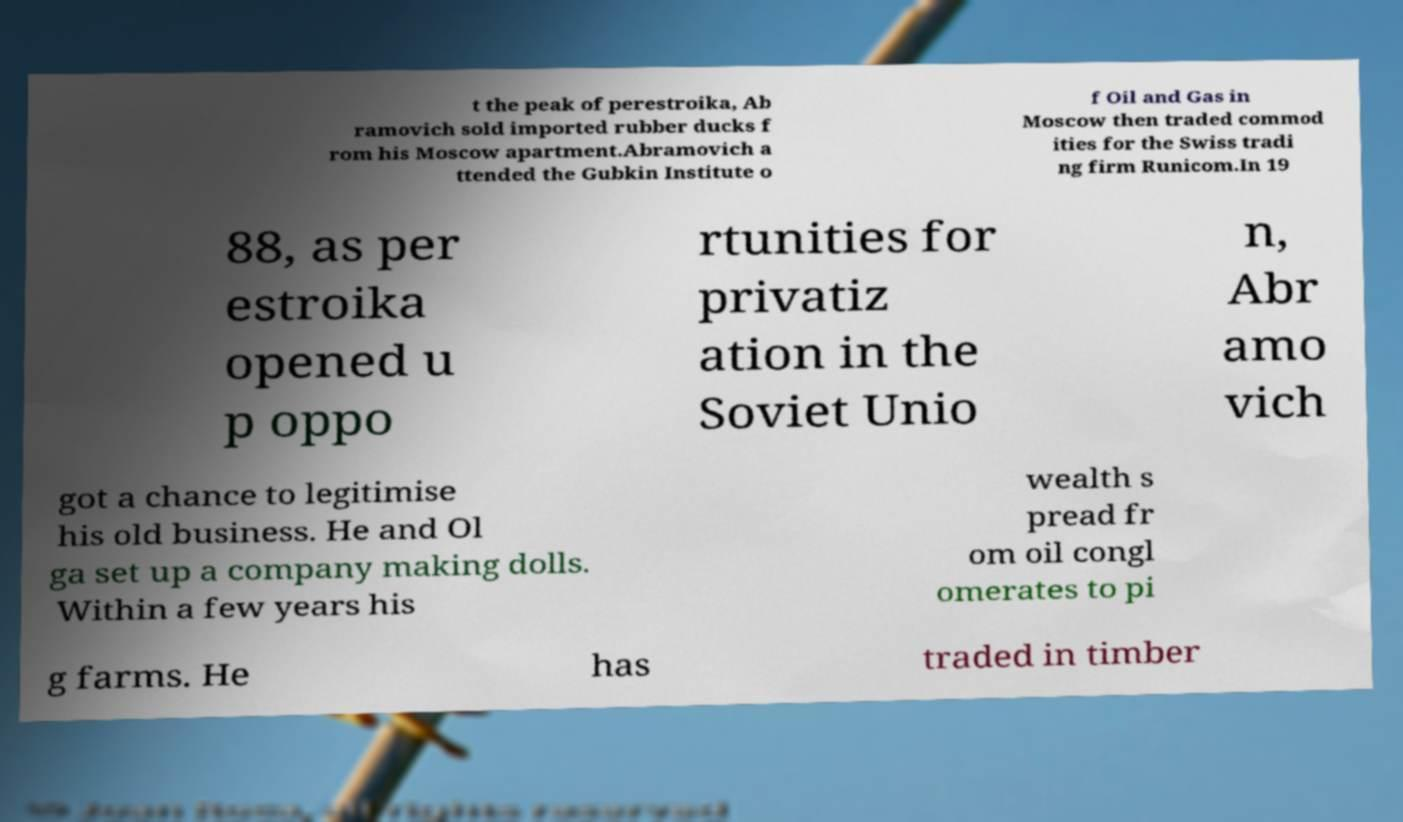There's text embedded in this image that I need extracted. Can you transcribe it verbatim? t the peak of perestroika, Ab ramovich sold imported rubber ducks f rom his Moscow apartment.Abramovich a ttended the Gubkin Institute o f Oil and Gas in Moscow then traded commod ities for the Swiss tradi ng firm Runicom.In 19 88, as per estroika opened u p oppo rtunities for privatiz ation in the Soviet Unio n, Abr amo vich got a chance to legitimise his old business. He and Ol ga set up a company making dolls. Within a few years his wealth s pread fr om oil congl omerates to pi g farms. He has traded in timber 